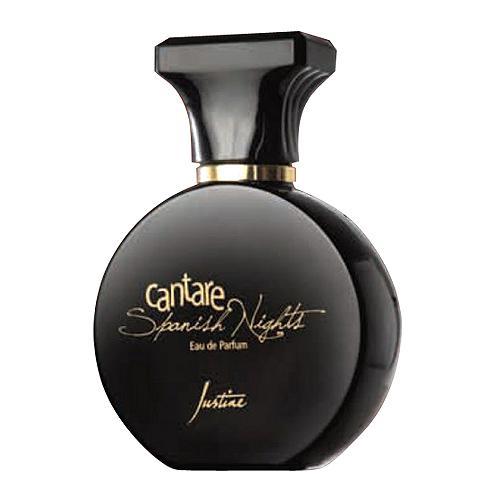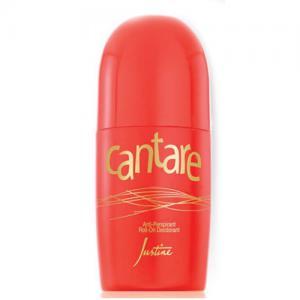The first image is the image on the left, the second image is the image on the right. Analyze the images presented: Is the assertion "there is at least one perfume bottle with a clear cap" valid? Answer yes or no. No. The first image is the image on the left, the second image is the image on the right. Considering the images on both sides, is "The right image contains a slender perfume container that is predominately red." valid? Answer yes or no. Yes. 